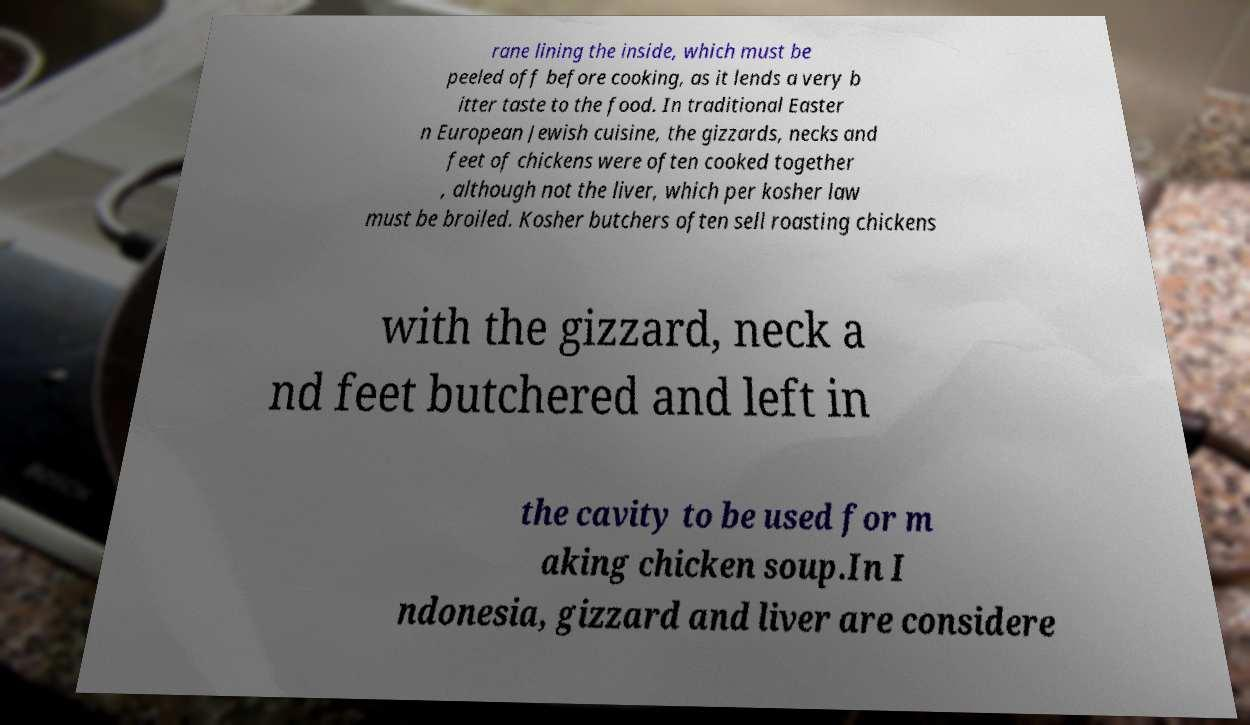Could you assist in decoding the text presented in this image and type it out clearly? rane lining the inside, which must be peeled off before cooking, as it lends a very b itter taste to the food. In traditional Easter n European Jewish cuisine, the gizzards, necks and feet of chickens were often cooked together , although not the liver, which per kosher law must be broiled. Kosher butchers often sell roasting chickens with the gizzard, neck a nd feet butchered and left in the cavity to be used for m aking chicken soup.In I ndonesia, gizzard and liver are considere 